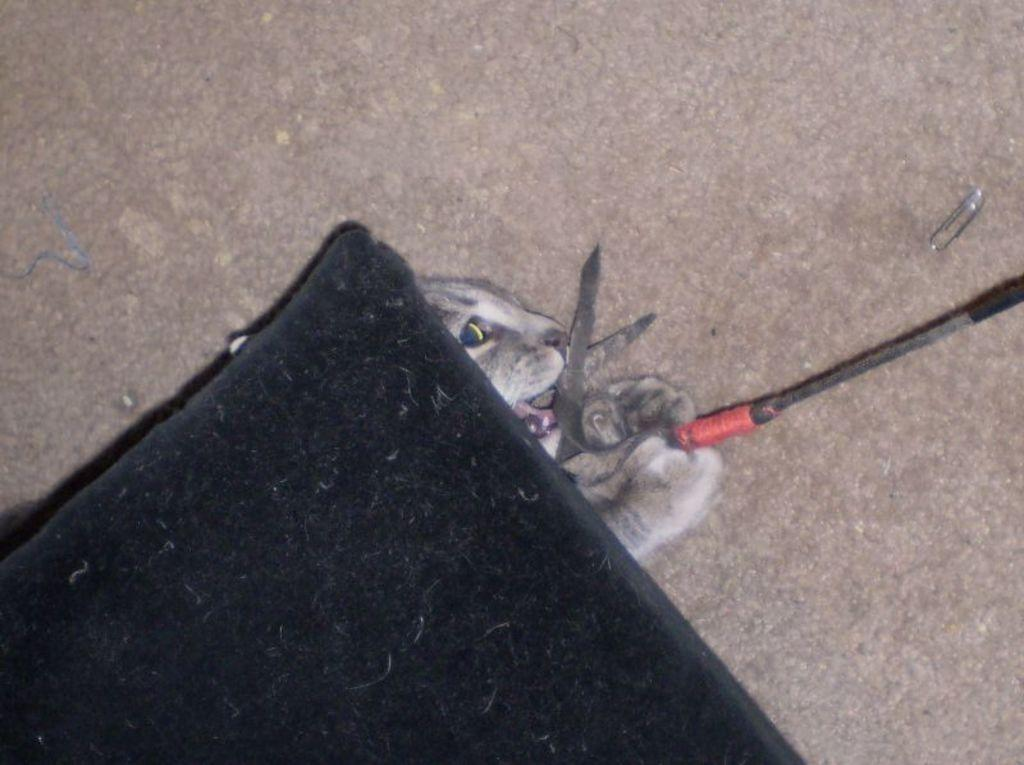What type of animal is in the image? There is a cat in the image. What object is also present in the image? There are scissors in the image. What color is the wire in the image? The wire in the image is black-colored. What type of apple is being used for addition in the image? There is no apple or addition activity present in the image. 